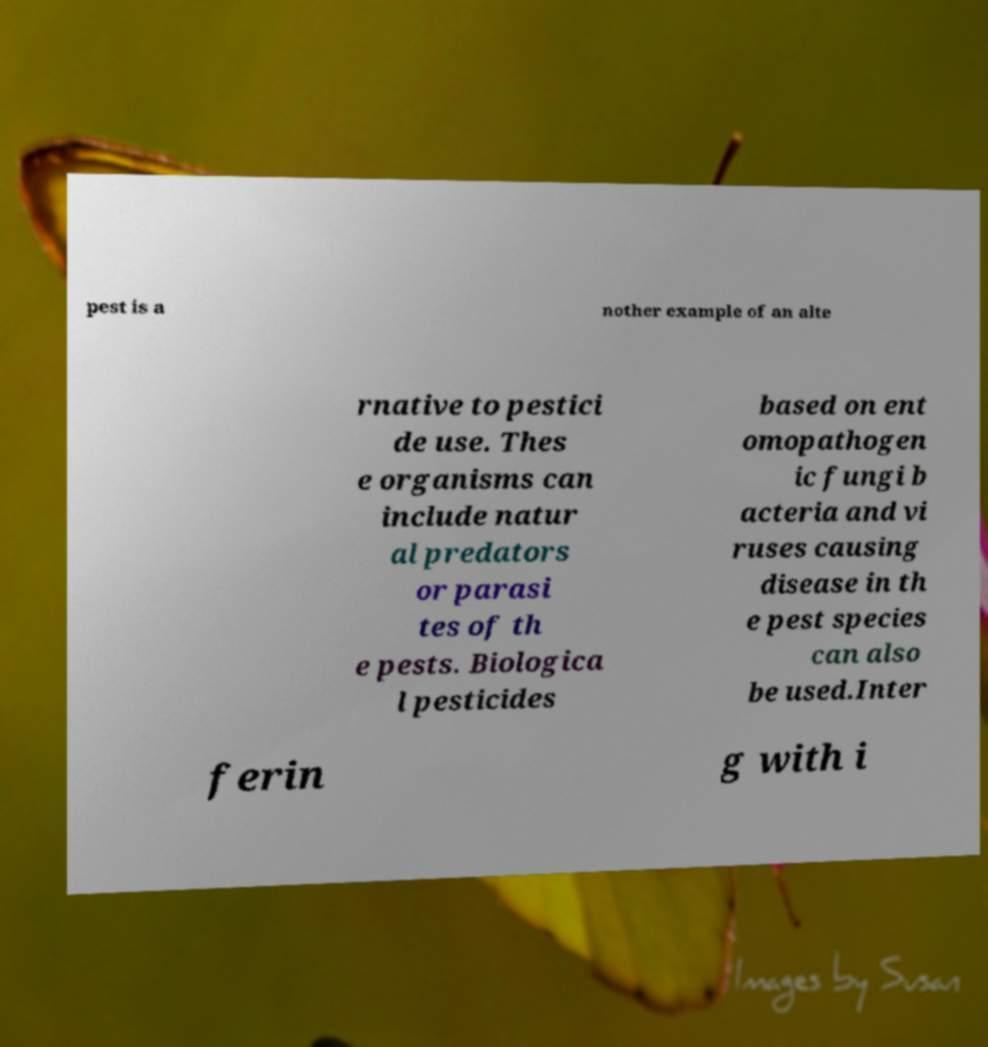Could you extract and type out the text from this image? pest is a nother example of an alte rnative to pestici de use. Thes e organisms can include natur al predators or parasi tes of th e pests. Biologica l pesticides based on ent omopathogen ic fungi b acteria and vi ruses causing disease in th e pest species can also be used.Inter ferin g with i 